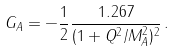Convert formula to latex. <formula><loc_0><loc_0><loc_500><loc_500>G _ { A } = - \frac { 1 } { 2 } \frac { 1 . 2 6 7 } { ( 1 + Q ^ { 2 } / M _ { A } ^ { 2 } ) ^ { 2 } } \, .</formula> 